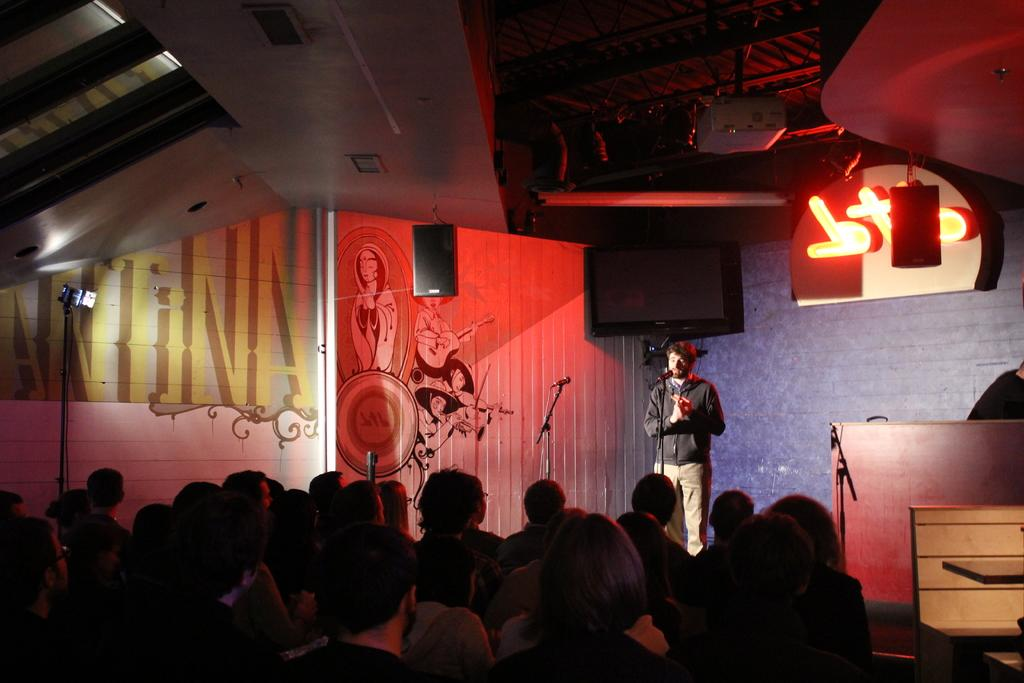What is the man near in the image? The man is standing near a microphone. What else can be seen in the image besides the man and the microphone? People are standing in the image, and there is a television present. What object is used for amplifying sound in the image? A speaker is visible in the image. What type of structure is in the background of the image? There is a wall in the image. What device is used for displaying images or videos in the image? There is a roof with a projector in the image. What type of caption is written on the wall in the image? There is no caption written on the wall in the image. How many trees are visible in the image? There are no trees visible in the image. 